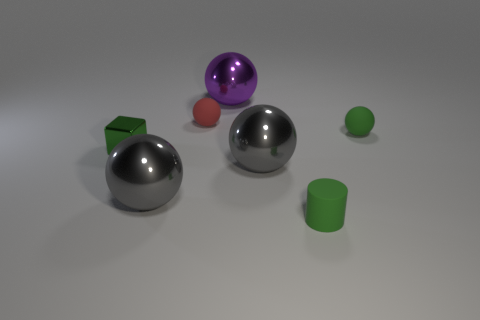Is the number of gray metal spheres greater than the number of small rubber things?
Provide a succinct answer. No. How many other objects are the same color as the small cylinder?
Ensure brevity in your answer.  2. Are the purple ball and the tiny cylinder right of the small red thing made of the same material?
Provide a succinct answer. No. How many large purple shiny balls are right of the green rubber thing that is behind the tiny green matte object left of the green rubber ball?
Give a very brief answer. 0. Is the number of big purple objects to the right of the purple thing less than the number of green objects that are behind the matte cylinder?
Keep it short and to the point. Yes. What number of other objects are there of the same material as the red thing?
Provide a succinct answer. 2. There is a cylinder that is the same size as the green block; what is its material?
Provide a succinct answer. Rubber. How many purple things are big metallic objects or small cylinders?
Ensure brevity in your answer.  1. The thing that is both right of the red rubber thing and behind the green ball is what color?
Make the answer very short. Purple. Is the material of the large object that is left of the large purple ball the same as the green thing that is to the right of the small cylinder?
Ensure brevity in your answer.  No. 